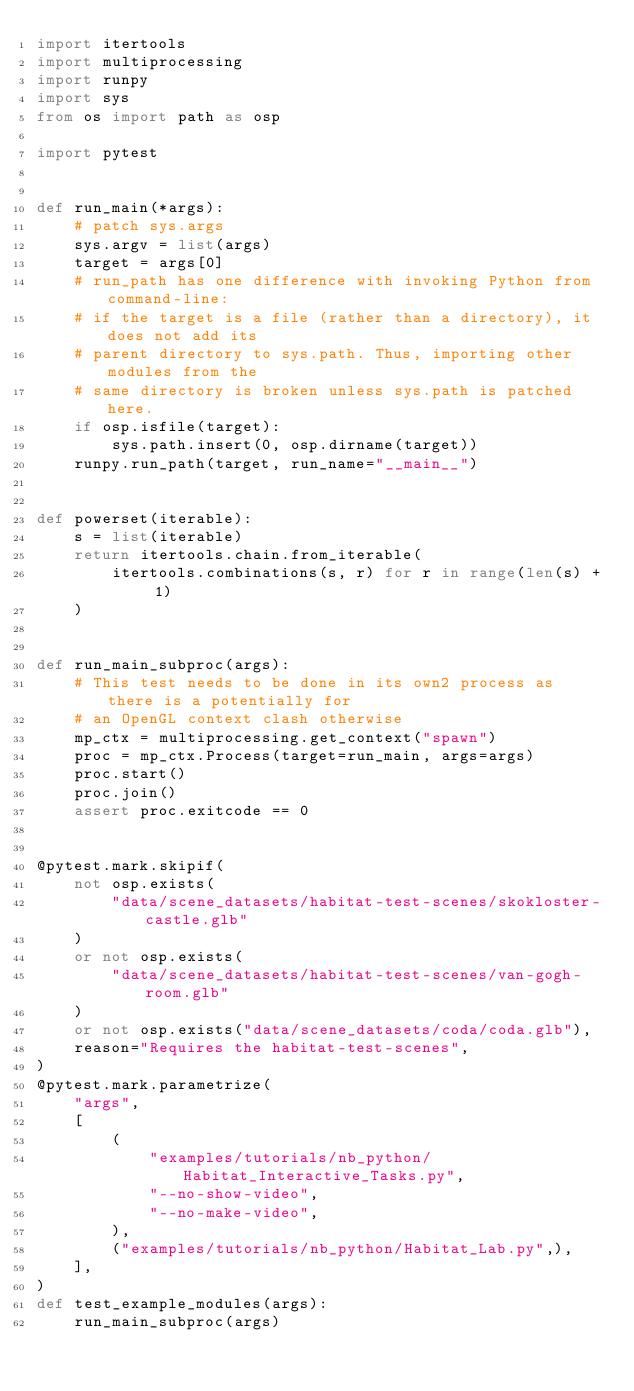Convert code to text. <code><loc_0><loc_0><loc_500><loc_500><_Python_>import itertools
import multiprocessing
import runpy
import sys
from os import path as osp

import pytest


def run_main(*args):
    # patch sys.args
    sys.argv = list(args)
    target = args[0]
    # run_path has one difference with invoking Python from command-line:
    # if the target is a file (rather than a directory), it does not add its
    # parent directory to sys.path. Thus, importing other modules from the
    # same directory is broken unless sys.path is patched here.
    if osp.isfile(target):
        sys.path.insert(0, osp.dirname(target))
    runpy.run_path(target, run_name="__main__")


def powerset(iterable):
    s = list(iterable)
    return itertools.chain.from_iterable(
        itertools.combinations(s, r) for r in range(len(s) + 1)
    )


def run_main_subproc(args):
    # This test needs to be done in its own2 process as there is a potentially for
    # an OpenGL context clash otherwise
    mp_ctx = multiprocessing.get_context("spawn")
    proc = mp_ctx.Process(target=run_main, args=args)
    proc.start()
    proc.join()
    assert proc.exitcode == 0


@pytest.mark.skipif(
    not osp.exists(
        "data/scene_datasets/habitat-test-scenes/skokloster-castle.glb"
    )
    or not osp.exists(
        "data/scene_datasets/habitat-test-scenes/van-gogh-room.glb"
    )
    or not osp.exists("data/scene_datasets/coda/coda.glb"),
    reason="Requires the habitat-test-scenes",
)
@pytest.mark.parametrize(
    "args",
    [
        (
            "examples/tutorials/nb_python/Habitat_Interactive_Tasks.py",
            "--no-show-video",
            "--no-make-video",
        ),
        ("examples/tutorials/nb_python/Habitat_Lab.py",),
    ],
)
def test_example_modules(args):
    run_main_subproc(args)
</code> 